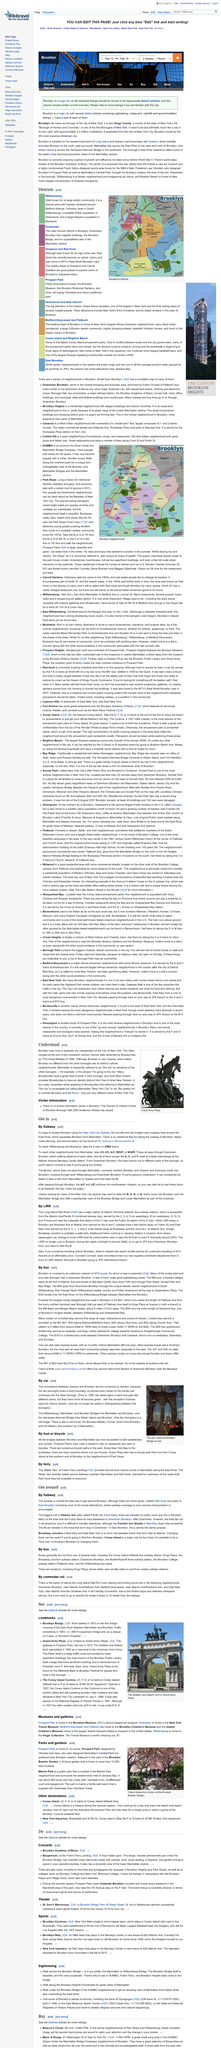Draw attention to some important aspects in this diagram. The Brooklyn Museum is located in Prospect Park. Yes, churches and synagogues do have concerts. Information is provided for concerts. In the opinion of Brooklynites, "The Great Mistake of 1898" refers to the date when their beloved city lost its independence and became incorporated into the City of New York. This event is perceived as a tragic mistake that compromised the unique identity and character of Brooklyn. Beacon's Closet is home to incredibly cheap and hip second-hand stores, offering a wide variety of affordable and trendy clothing and accessories. 